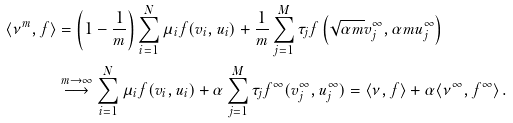Convert formula to latex. <formula><loc_0><loc_0><loc_500><loc_500>\langle \nu ^ { m } , f \rangle & = \left ( 1 - \frac { 1 } { m } \right ) \sum _ { i = 1 } ^ { N } \mu _ { i } f ( v _ { i } , u _ { i } ) + \frac { 1 } { m } \sum _ { j = 1 } ^ { M } \tau _ { j } f \left ( \sqrt { \alpha m } v _ { j } ^ { \infty } , \alpha m u _ { j } ^ { \infty } \right ) \\ & \overset { m \to \infty } \longrightarrow \sum _ { i = 1 } ^ { N } \mu _ { i } f ( v _ { i } , u _ { i } ) + \alpha \sum _ { j = 1 } ^ { M } \tau _ { j } f ^ { \infty } ( v _ { j } ^ { \infty } , u _ { j } ^ { \infty } ) = \langle \nu , f \rangle + \alpha \langle \nu ^ { \infty } , f ^ { \infty } \rangle \, .</formula> 